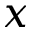<formula> <loc_0><loc_0><loc_500><loc_500>x</formula> 